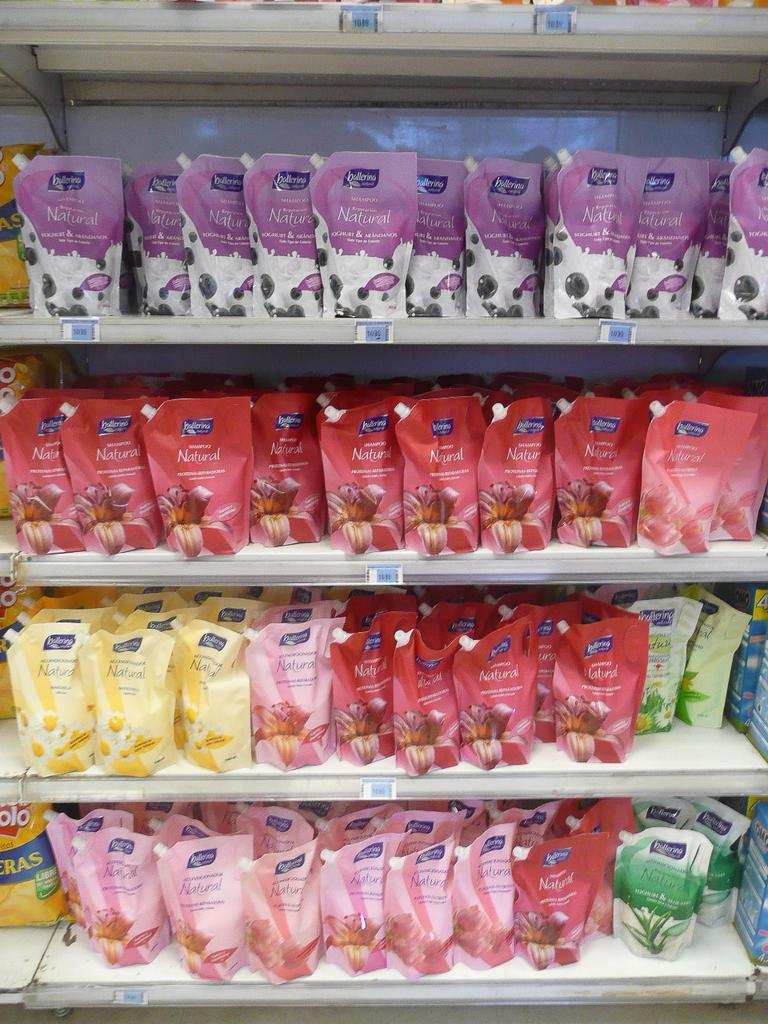<image>
Give a short and clear explanation of the subsequent image. Four rows of Natural ballerian shampo of red, purple, pink, and yellow bags. 